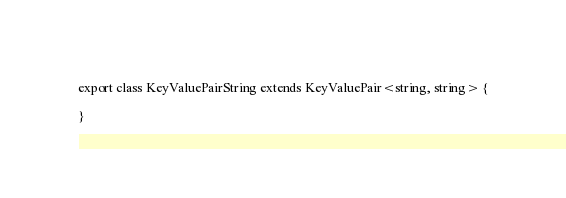<code> <loc_0><loc_0><loc_500><loc_500><_TypeScript_>
export class KeyValuePairString extends KeyValuePair<string, string> {

}
</code> 